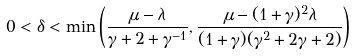<formula> <loc_0><loc_0><loc_500><loc_500>0 < \delta < \min \left ( \frac { \mu - \lambda } { \gamma + 2 + \gamma ^ { - 1 } } , \frac { \mu - ( 1 + \gamma ) ^ { 2 } \lambda } { ( 1 + \gamma ) ( \gamma ^ { 2 } + 2 \gamma + 2 ) } \right )</formula> 